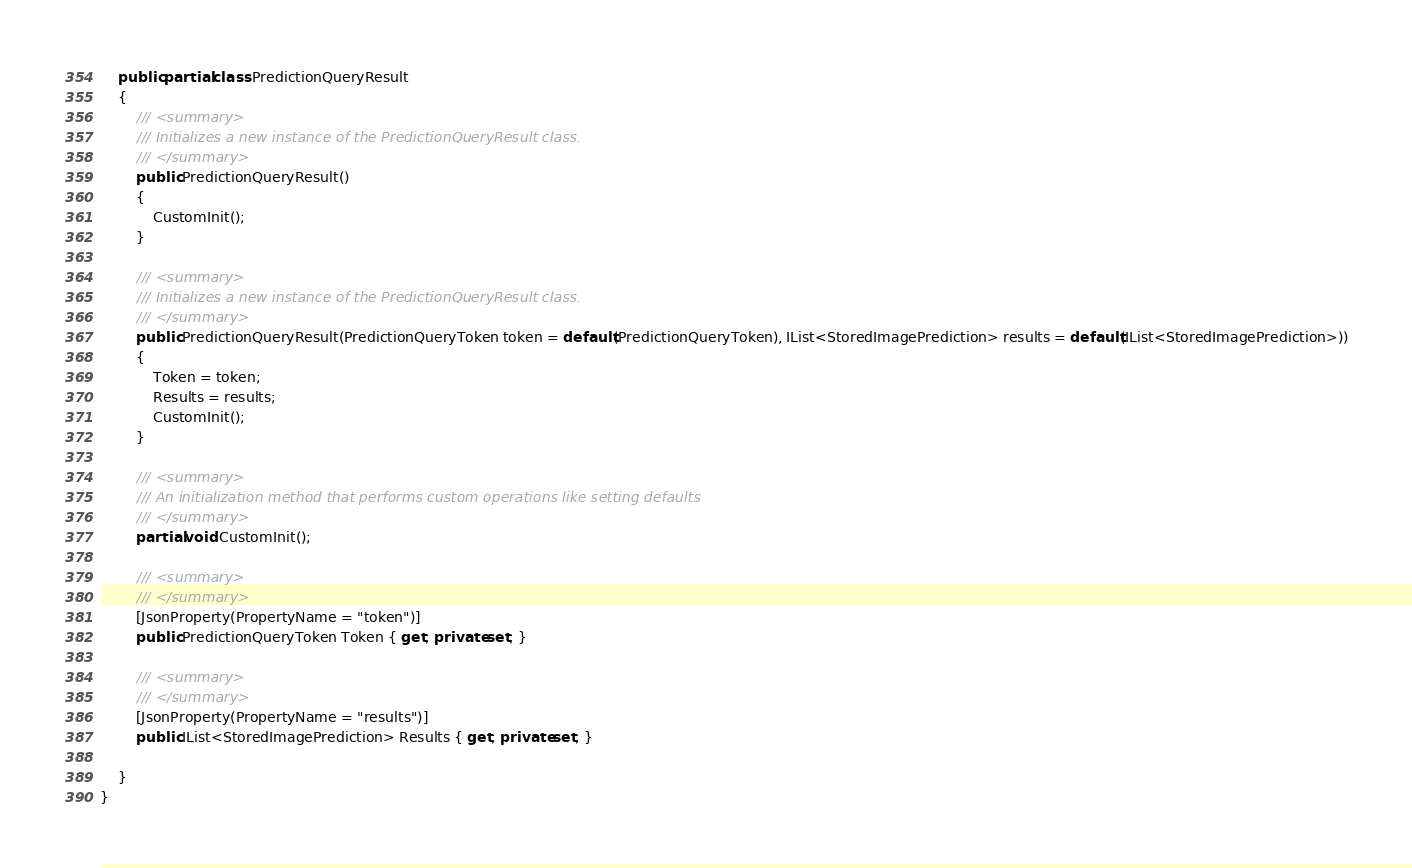<code> <loc_0><loc_0><loc_500><loc_500><_C#_>
    public partial class PredictionQueryResult
    {
        /// <summary>
        /// Initializes a new instance of the PredictionQueryResult class.
        /// </summary>
        public PredictionQueryResult()
        {
            CustomInit();
        }

        /// <summary>
        /// Initializes a new instance of the PredictionQueryResult class.
        /// </summary>
        public PredictionQueryResult(PredictionQueryToken token = default(PredictionQueryToken), IList<StoredImagePrediction> results = default(IList<StoredImagePrediction>))
        {
            Token = token;
            Results = results;
            CustomInit();
        }

        /// <summary>
        /// An initialization method that performs custom operations like setting defaults
        /// </summary>
        partial void CustomInit();

        /// <summary>
        /// </summary>
        [JsonProperty(PropertyName = "token")]
        public PredictionQueryToken Token { get; private set; }

        /// <summary>
        /// </summary>
        [JsonProperty(PropertyName = "results")]
        public IList<StoredImagePrediction> Results { get; private set; }

    }
}
</code> 